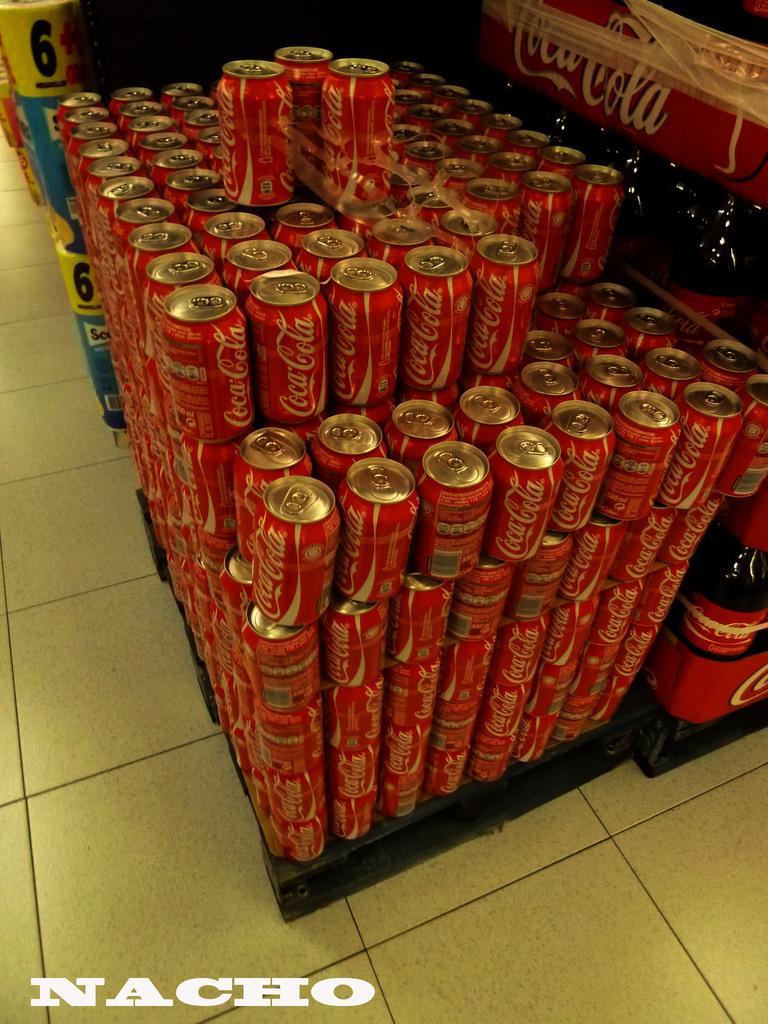Can you describe this image briefly? In this picture I can see so many coca cola tins arranged in an order one upon the another , there are coca cola bottles arranged in an order, and in the background there are some items and there is a watermark on the image. 